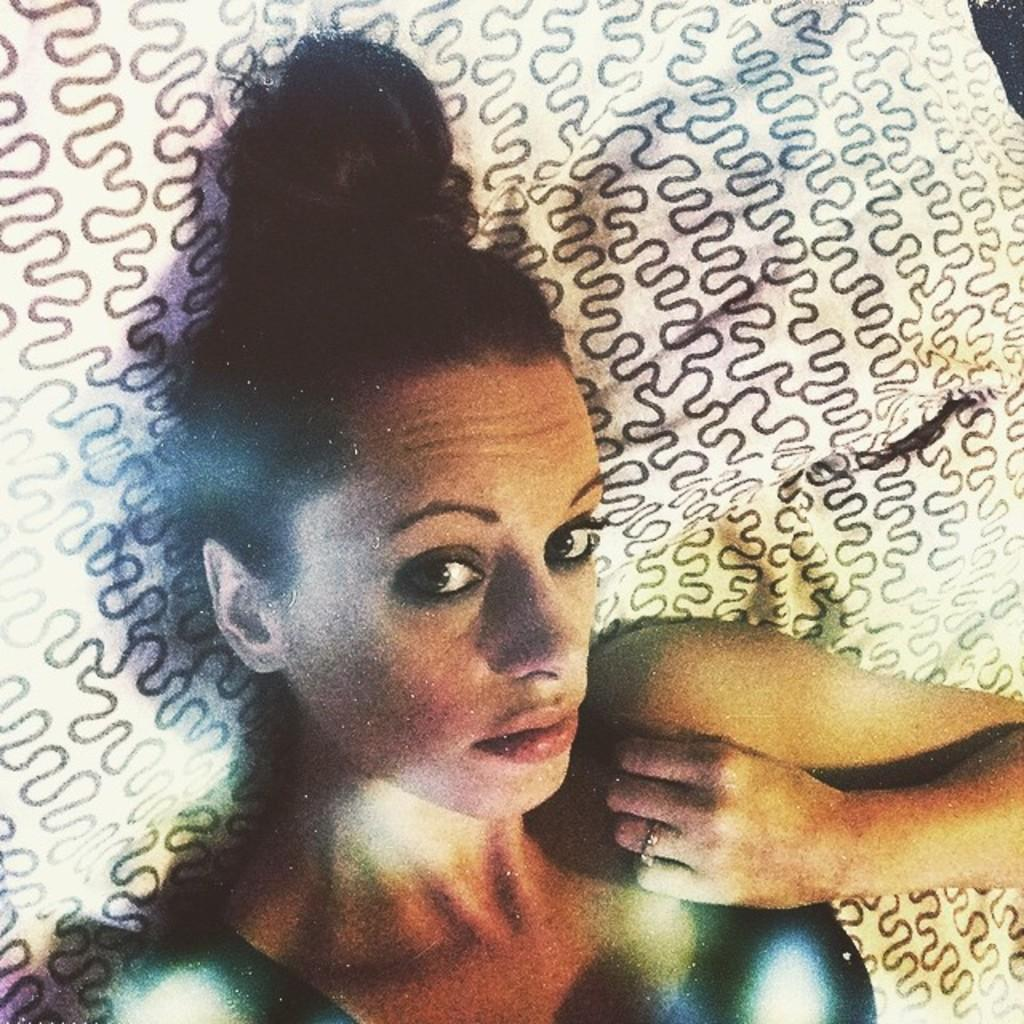Who is present in the image? There is a woman in the image. What is the woman doing in the image? The woman is sleeping on the bed. What is covering the bed in the image? There is a blanket on the bed. Can you describe the blanket in the image? The blanket has a design. What month is it in the image? The month cannot be determined from the image, as it does not contain any information about the time or date. 